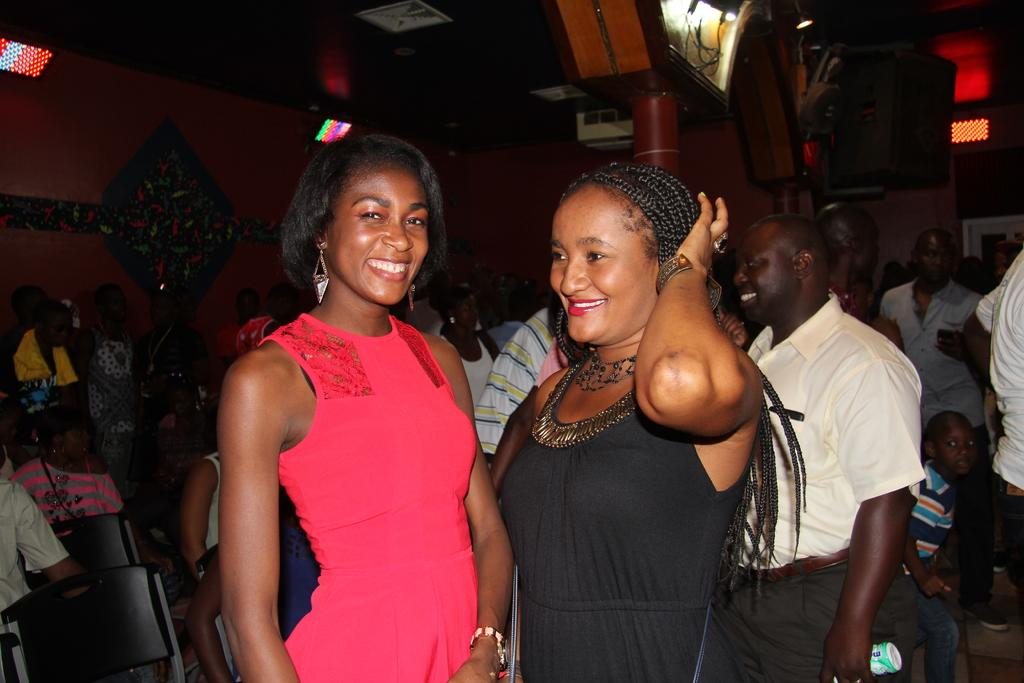What are the people in the image doing? There are people standing on the floor and sitting on chairs in the image. What can be seen in the background of the image? There are electric lights, speakers, projectors, and toys in the background of the image. Where is the kettle located in the image? There is no kettle present in the image. What is the tiger doing in the image? There is no tiger present in the image. 